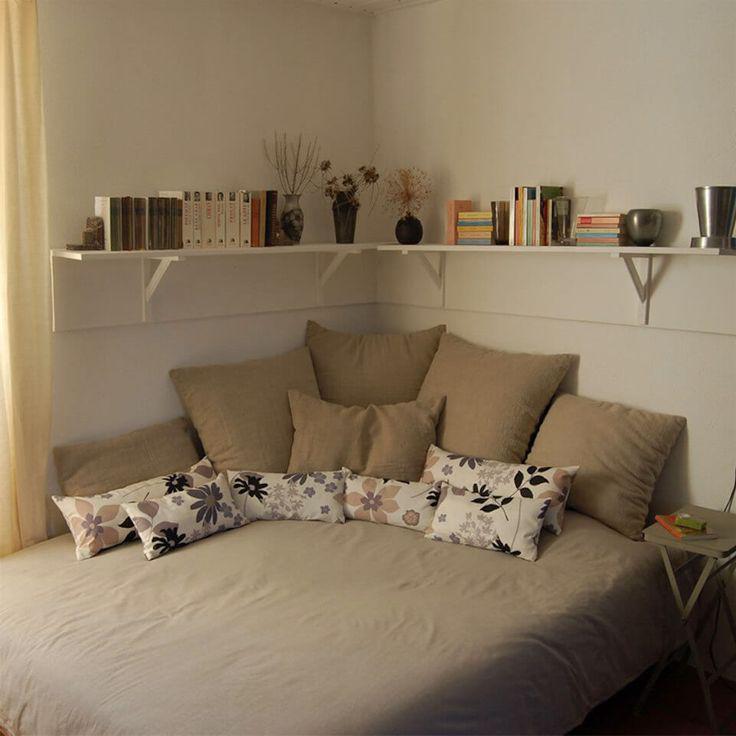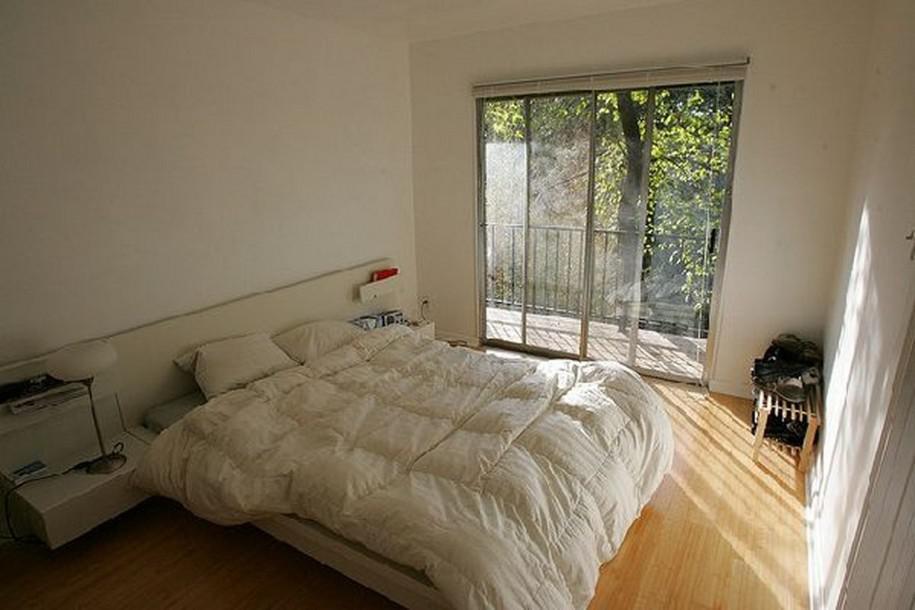The first image is the image on the left, the second image is the image on the right. For the images displayed, is the sentence "The left image includes a white corner shelf." factually correct? Answer yes or no. Yes. 